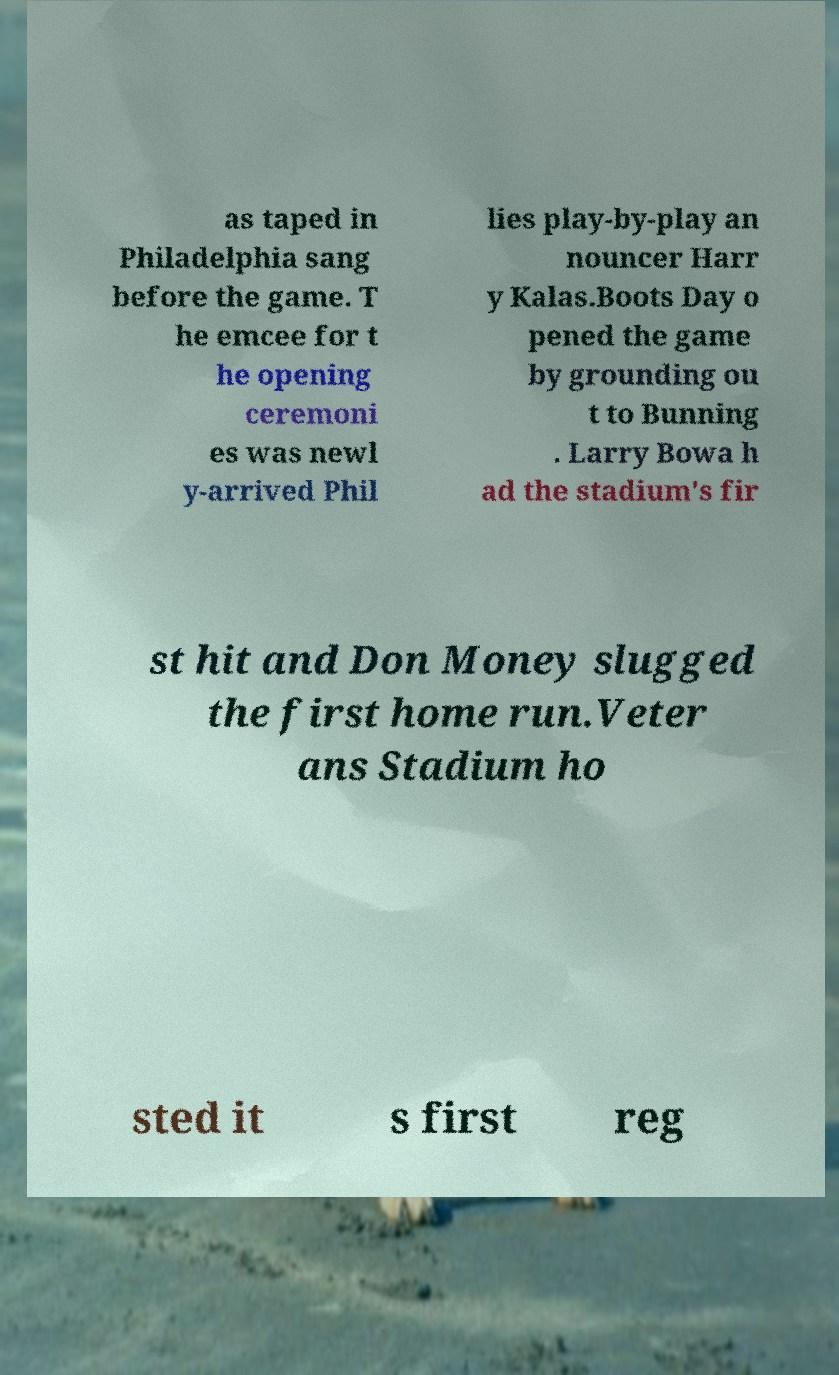Please read and relay the text visible in this image. What does it say? as taped in Philadelphia sang before the game. T he emcee for t he opening ceremoni es was newl y-arrived Phil lies play-by-play an nouncer Harr y Kalas.Boots Day o pened the game by grounding ou t to Bunning . Larry Bowa h ad the stadium's fir st hit and Don Money slugged the first home run.Veter ans Stadium ho sted it s first reg 